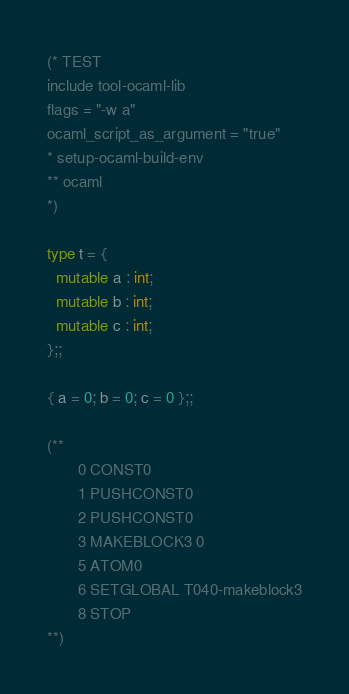Convert code to text. <code><loc_0><loc_0><loc_500><loc_500><_OCaml_>(* TEST
include tool-ocaml-lib
flags = "-w a"
ocaml_script_as_argument = "true"
* setup-ocaml-build-env
** ocaml
*)

type t = {
  mutable a : int;
  mutable b : int;
  mutable c : int;
};;

{ a = 0; b = 0; c = 0 };;

(**
       0 CONST0
       1 PUSHCONST0
       2 PUSHCONST0
       3 MAKEBLOCK3 0
       5 ATOM0
       6 SETGLOBAL T040-makeblock3
       8 STOP
**)
</code> 